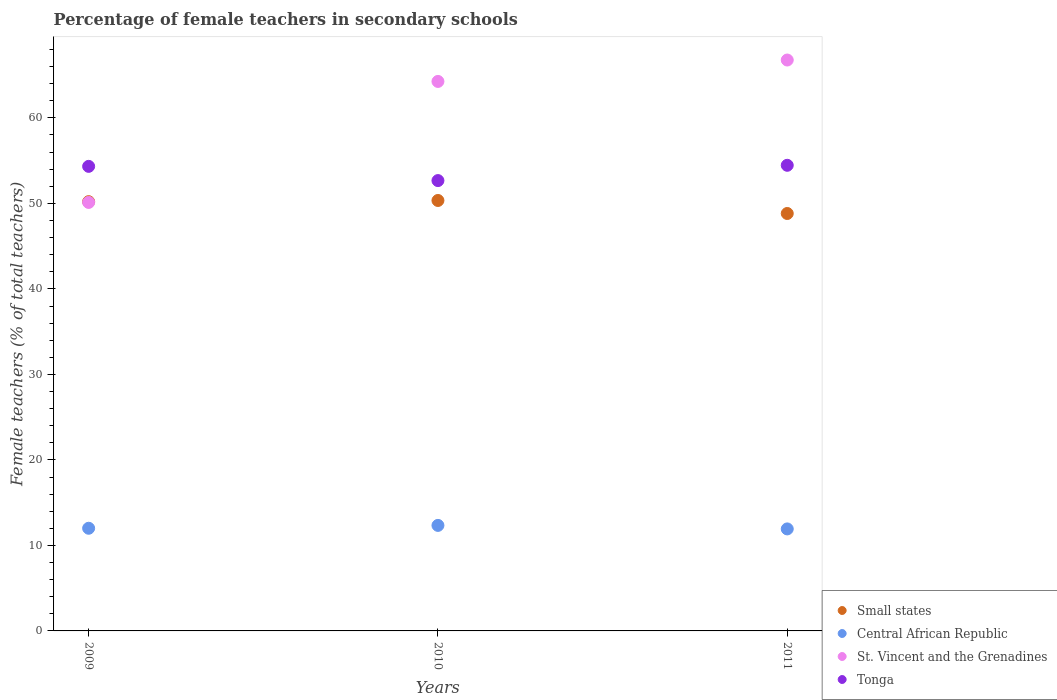Is the number of dotlines equal to the number of legend labels?
Provide a short and direct response. Yes. What is the percentage of female teachers in Tonga in 2009?
Provide a short and direct response. 54.33. Across all years, what is the maximum percentage of female teachers in Small states?
Offer a terse response. 50.34. Across all years, what is the minimum percentage of female teachers in Central African Republic?
Make the answer very short. 11.93. In which year was the percentage of female teachers in Small states minimum?
Provide a succinct answer. 2011. What is the total percentage of female teachers in Central African Republic in the graph?
Your response must be concise. 36.28. What is the difference between the percentage of female teachers in Central African Republic in 2009 and that in 2010?
Ensure brevity in your answer.  -0.33. What is the difference between the percentage of female teachers in Small states in 2011 and the percentage of female teachers in St. Vincent and the Grenadines in 2010?
Provide a succinct answer. -15.44. What is the average percentage of female teachers in Small states per year?
Offer a terse response. 49.79. In the year 2009, what is the difference between the percentage of female teachers in Small states and percentage of female teachers in Tonga?
Ensure brevity in your answer.  -4.13. In how many years, is the percentage of female teachers in Small states greater than 54 %?
Offer a terse response. 0. What is the ratio of the percentage of female teachers in St. Vincent and the Grenadines in 2009 to that in 2011?
Your answer should be very brief. 0.75. What is the difference between the highest and the second highest percentage of female teachers in Tonga?
Ensure brevity in your answer.  0.12. What is the difference between the highest and the lowest percentage of female teachers in Central African Republic?
Your answer should be compact. 0.41. Does the percentage of female teachers in Central African Republic monotonically increase over the years?
Your answer should be compact. No. Is the percentage of female teachers in Tonga strictly less than the percentage of female teachers in Central African Republic over the years?
Provide a succinct answer. No. How many years are there in the graph?
Your answer should be compact. 3. What is the difference between two consecutive major ticks on the Y-axis?
Give a very brief answer. 10. Does the graph contain grids?
Provide a short and direct response. No. Where does the legend appear in the graph?
Keep it short and to the point. Bottom right. How are the legend labels stacked?
Provide a short and direct response. Vertical. What is the title of the graph?
Provide a short and direct response. Percentage of female teachers in secondary schools. What is the label or title of the Y-axis?
Offer a terse response. Female teachers (% of total teachers). What is the Female teachers (% of total teachers) in Small states in 2009?
Your response must be concise. 50.2. What is the Female teachers (% of total teachers) of Central African Republic in 2009?
Your answer should be compact. 12.01. What is the Female teachers (% of total teachers) of St. Vincent and the Grenadines in 2009?
Your answer should be very brief. 50.11. What is the Female teachers (% of total teachers) of Tonga in 2009?
Offer a terse response. 54.33. What is the Female teachers (% of total teachers) in Small states in 2010?
Give a very brief answer. 50.34. What is the Female teachers (% of total teachers) of Central African Republic in 2010?
Your answer should be compact. 12.34. What is the Female teachers (% of total teachers) of St. Vincent and the Grenadines in 2010?
Your answer should be compact. 64.26. What is the Female teachers (% of total teachers) in Tonga in 2010?
Make the answer very short. 52.67. What is the Female teachers (% of total teachers) of Small states in 2011?
Provide a succinct answer. 48.82. What is the Female teachers (% of total teachers) in Central African Republic in 2011?
Keep it short and to the point. 11.93. What is the Female teachers (% of total teachers) of St. Vincent and the Grenadines in 2011?
Keep it short and to the point. 66.77. What is the Female teachers (% of total teachers) in Tonga in 2011?
Provide a short and direct response. 54.46. Across all years, what is the maximum Female teachers (% of total teachers) of Small states?
Provide a succinct answer. 50.34. Across all years, what is the maximum Female teachers (% of total teachers) in Central African Republic?
Ensure brevity in your answer.  12.34. Across all years, what is the maximum Female teachers (% of total teachers) in St. Vincent and the Grenadines?
Your response must be concise. 66.77. Across all years, what is the maximum Female teachers (% of total teachers) of Tonga?
Provide a short and direct response. 54.46. Across all years, what is the minimum Female teachers (% of total teachers) in Small states?
Your answer should be compact. 48.82. Across all years, what is the minimum Female teachers (% of total teachers) of Central African Republic?
Ensure brevity in your answer.  11.93. Across all years, what is the minimum Female teachers (% of total teachers) in St. Vincent and the Grenadines?
Offer a very short reply. 50.11. Across all years, what is the minimum Female teachers (% of total teachers) in Tonga?
Provide a short and direct response. 52.67. What is the total Female teachers (% of total teachers) in Small states in the graph?
Your answer should be very brief. 149.36. What is the total Female teachers (% of total teachers) in Central African Republic in the graph?
Make the answer very short. 36.28. What is the total Female teachers (% of total teachers) of St. Vincent and the Grenadines in the graph?
Provide a short and direct response. 181.15. What is the total Female teachers (% of total teachers) of Tonga in the graph?
Provide a succinct answer. 161.46. What is the difference between the Female teachers (% of total teachers) of Small states in 2009 and that in 2010?
Provide a short and direct response. -0.14. What is the difference between the Female teachers (% of total teachers) of Central African Republic in 2009 and that in 2010?
Your answer should be compact. -0.33. What is the difference between the Female teachers (% of total teachers) in St. Vincent and the Grenadines in 2009 and that in 2010?
Provide a succinct answer. -14.15. What is the difference between the Female teachers (% of total teachers) of Tonga in 2009 and that in 2010?
Keep it short and to the point. 1.66. What is the difference between the Female teachers (% of total teachers) in Small states in 2009 and that in 2011?
Your answer should be very brief. 1.38. What is the difference between the Female teachers (% of total teachers) of Central African Republic in 2009 and that in 2011?
Your answer should be very brief. 0.08. What is the difference between the Female teachers (% of total teachers) of St. Vincent and the Grenadines in 2009 and that in 2011?
Your answer should be very brief. -16.66. What is the difference between the Female teachers (% of total teachers) in Tonga in 2009 and that in 2011?
Offer a very short reply. -0.12. What is the difference between the Female teachers (% of total teachers) in Small states in 2010 and that in 2011?
Your response must be concise. 1.52. What is the difference between the Female teachers (% of total teachers) of Central African Republic in 2010 and that in 2011?
Give a very brief answer. 0.41. What is the difference between the Female teachers (% of total teachers) of St. Vincent and the Grenadines in 2010 and that in 2011?
Provide a short and direct response. -2.5. What is the difference between the Female teachers (% of total teachers) of Tonga in 2010 and that in 2011?
Your answer should be very brief. -1.79. What is the difference between the Female teachers (% of total teachers) of Small states in 2009 and the Female teachers (% of total teachers) of Central African Republic in 2010?
Your answer should be compact. 37.86. What is the difference between the Female teachers (% of total teachers) in Small states in 2009 and the Female teachers (% of total teachers) in St. Vincent and the Grenadines in 2010?
Make the answer very short. -14.06. What is the difference between the Female teachers (% of total teachers) in Small states in 2009 and the Female teachers (% of total teachers) in Tonga in 2010?
Offer a terse response. -2.47. What is the difference between the Female teachers (% of total teachers) in Central African Republic in 2009 and the Female teachers (% of total teachers) in St. Vincent and the Grenadines in 2010?
Your answer should be very brief. -52.26. What is the difference between the Female teachers (% of total teachers) of Central African Republic in 2009 and the Female teachers (% of total teachers) of Tonga in 2010?
Provide a succinct answer. -40.66. What is the difference between the Female teachers (% of total teachers) in St. Vincent and the Grenadines in 2009 and the Female teachers (% of total teachers) in Tonga in 2010?
Your answer should be very brief. -2.56. What is the difference between the Female teachers (% of total teachers) in Small states in 2009 and the Female teachers (% of total teachers) in Central African Republic in 2011?
Keep it short and to the point. 38.27. What is the difference between the Female teachers (% of total teachers) in Small states in 2009 and the Female teachers (% of total teachers) in St. Vincent and the Grenadines in 2011?
Make the answer very short. -16.57. What is the difference between the Female teachers (% of total teachers) of Small states in 2009 and the Female teachers (% of total teachers) of Tonga in 2011?
Your answer should be compact. -4.25. What is the difference between the Female teachers (% of total teachers) of Central African Republic in 2009 and the Female teachers (% of total teachers) of St. Vincent and the Grenadines in 2011?
Offer a terse response. -54.76. What is the difference between the Female teachers (% of total teachers) in Central African Republic in 2009 and the Female teachers (% of total teachers) in Tonga in 2011?
Your response must be concise. -42.45. What is the difference between the Female teachers (% of total teachers) in St. Vincent and the Grenadines in 2009 and the Female teachers (% of total teachers) in Tonga in 2011?
Offer a terse response. -4.34. What is the difference between the Female teachers (% of total teachers) in Small states in 2010 and the Female teachers (% of total teachers) in Central African Republic in 2011?
Make the answer very short. 38.41. What is the difference between the Female teachers (% of total teachers) in Small states in 2010 and the Female teachers (% of total teachers) in St. Vincent and the Grenadines in 2011?
Provide a short and direct response. -16.43. What is the difference between the Female teachers (% of total teachers) in Small states in 2010 and the Female teachers (% of total teachers) in Tonga in 2011?
Your answer should be compact. -4.11. What is the difference between the Female teachers (% of total teachers) in Central African Republic in 2010 and the Female teachers (% of total teachers) in St. Vincent and the Grenadines in 2011?
Your response must be concise. -54.43. What is the difference between the Female teachers (% of total teachers) in Central African Republic in 2010 and the Female teachers (% of total teachers) in Tonga in 2011?
Your answer should be compact. -42.12. What is the difference between the Female teachers (% of total teachers) in St. Vincent and the Grenadines in 2010 and the Female teachers (% of total teachers) in Tonga in 2011?
Provide a succinct answer. 9.81. What is the average Female teachers (% of total teachers) in Small states per year?
Your response must be concise. 49.79. What is the average Female teachers (% of total teachers) in Central African Republic per year?
Give a very brief answer. 12.09. What is the average Female teachers (% of total teachers) of St. Vincent and the Grenadines per year?
Offer a terse response. 60.38. What is the average Female teachers (% of total teachers) in Tonga per year?
Your response must be concise. 53.82. In the year 2009, what is the difference between the Female teachers (% of total teachers) in Small states and Female teachers (% of total teachers) in Central African Republic?
Keep it short and to the point. 38.2. In the year 2009, what is the difference between the Female teachers (% of total teachers) in Small states and Female teachers (% of total teachers) in St. Vincent and the Grenadines?
Your answer should be very brief. 0.09. In the year 2009, what is the difference between the Female teachers (% of total teachers) of Small states and Female teachers (% of total teachers) of Tonga?
Keep it short and to the point. -4.13. In the year 2009, what is the difference between the Female teachers (% of total teachers) of Central African Republic and Female teachers (% of total teachers) of St. Vincent and the Grenadines?
Provide a succinct answer. -38.11. In the year 2009, what is the difference between the Female teachers (% of total teachers) in Central African Republic and Female teachers (% of total teachers) in Tonga?
Offer a terse response. -42.33. In the year 2009, what is the difference between the Female teachers (% of total teachers) in St. Vincent and the Grenadines and Female teachers (% of total teachers) in Tonga?
Keep it short and to the point. -4.22. In the year 2010, what is the difference between the Female teachers (% of total teachers) in Small states and Female teachers (% of total teachers) in Central African Republic?
Your response must be concise. 38. In the year 2010, what is the difference between the Female teachers (% of total teachers) of Small states and Female teachers (% of total teachers) of St. Vincent and the Grenadines?
Your response must be concise. -13.92. In the year 2010, what is the difference between the Female teachers (% of total teachers) in Small states and Female teachers (% of total teachers) in Tonga?
Your answer should be very brief. -2.33. In the year 2010, what is the difference between the Female teachers (% of total teachers) in Central African Republic and Female teachers (% of total teachers) in St. Vincent and the Grenadines?
Ensure brevity in your answer.  -51.92. In the year 2010, what is the difference between the Female teachers (% of total teachers) in Central African Republic and Female teachers (% of total teachers) in Tonga?
Your answer should be very brief. -40.33. In the year 2010, what is the difference between the Female teachers (% of total teachers) of St. Vincent and the Grenadines and Female teachers (% of total teachers) of Tonga?
Make the answer very short. 11.6. In the year 2011, what is the difference between the Female teachers (% of total teachers) of Small states and Female teachers (% of total teachers) of Central African Republic?
Offer a terse response. 36.89. In the year 2011, what is the difference between the Female teachers (% of total teachers) of Small states and Female teachers (% of total teachers) of St. Vincent and the Grenadines?
Make the answer very short. -17.95. In the year 2011, what is the difference between the Female teachers (% of total teachers) of Small states and Female teachers (% of total teachers) of Tonga?
Keep it short and to the point. -5.64. In the year 2011, what is the difference between the Female teachers (% of total teachers) in Central African Republic and Female teachers (% of total teachers) in St. Vincent and the Grenadines?
Your response must be concise. -54.84. In the year 2011, what is the difference between the Female teachers (% of total teachers) in Central African Republic and Female teachers (% of total teachers) in Tonga?
Offer a terse response. -42.53. In the year 2011, what is the difference between the Female teachers (% of total teachers) in St. Vincent and the Grenadines and Female teachers (% of total teachers) in Tonga?
Your answer should be very brief. 12.31. What is the ratio of the Female teachers (% of total teachers) of Central African Republic in 2009 to that in 2010?
Ensure brevity in your answer.  0.97. What is the ratio of the Female teachers (% of total teachers) in St. Vincent and the Grenadines in 2009 to that in 2010?
Keep it short and to the point. 0.78. What is the ratio of the Female teachers (% of total teachers) in Tonga in 2009 to that in 2010?
Give a very brief answer. 1.03. What is the ratio of the Female teachers (% of total teachers) of Small states in 2009 to that in 2011?
Keep it short and to the point. 1.03. What is the ratio of the Female teachers (% of total teachers) of Central African Republic in 2009 to that in 2011?
Your response must be concise. 1.01. What is the ratio of the Female teachers (% of total teachers) of St. Vincent and the Grenadines in 2009 to that in 2011?
Keep it short and to the point. 0.75. What is the ratio of the Female teachers (% of total teachers) of Small states in 2010 to that in 2011?
Your response must be concise. 1.03. What is the ratio of the Female teachers (% of total teachers) of Central African Republic in 2010 to that in 2011?
Make the answer very short. 1.03. What is the ratio of the Female teachers (% of total teachers) of St. Vincent and the Grenadines in 2010 to that in 2011?
Ensure brevity in your answer.  0.96. What is the ratio of the Female teachers (% of total teachers) of Tonga in 2010 to that in 2011?
Your response must be concise. 0.97. What is the difference between the highest and the second highest Female teachers (% of total teachers) of Small states?
Keep it short and to the point. 0.14. What is the difference between the highest and the second highest Female teachers (% of total teachers) in Central African Republic?
Your response must be concise. 0.33. What is the difference between the highest and the second highest Female teachers (% of total teachers) of St. Vincent and the Grenadines?
Your answer should be compact. 2.5. What is the difference between the highest and the second highest Female teachers (% of total teachers) of Tonga?
Make the answer very short. 0.12. What is the difference between the highest and the lowest Female teachers (% of total teachers) in Small states?
Make the answer very short. 1.52. What is the difference between the highest and the lowest Female teachers (% of total teachers) in Central African Republic?
Keep it short and to the point. 0.41. What is the difference between the highest and the lowest Female teachers (% of total teachers) of St. Vincent and the Grenadines?
Give a very brief answer. 16.66. What is the difference between the highest and the lowest Female teachers (% of total teachers) in Tonga?
Your response must be concise. 1.79. 